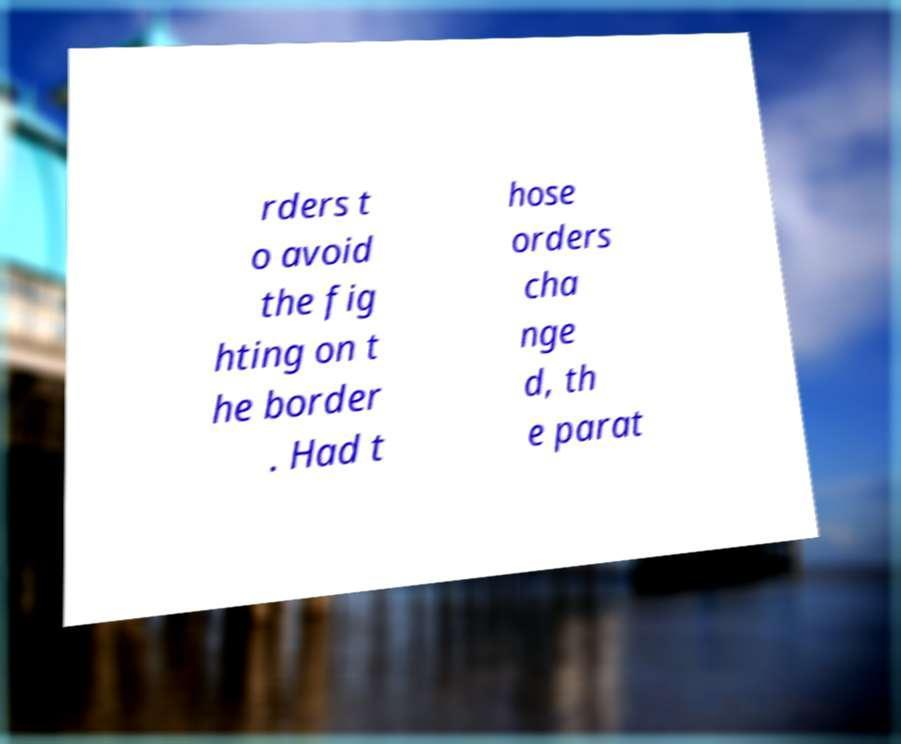What messages or text are displayed in this image? I need them in a readable, typed format. rders t o avoid the fig hting on t he border . Had t hose orders cha nge d, th e parat 